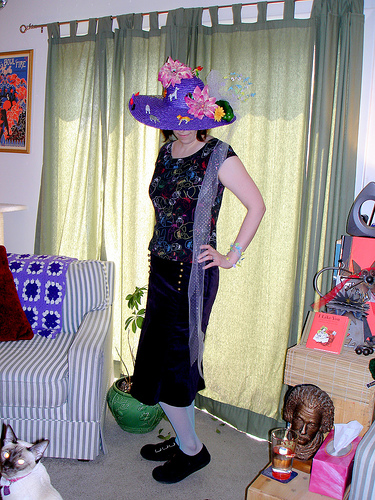<image>
Can you confirm if the woman is behind the plant? No. The woman is not behind the plant. From this viewpoint, the woman appears to be positioned elsewhere in the scene. 